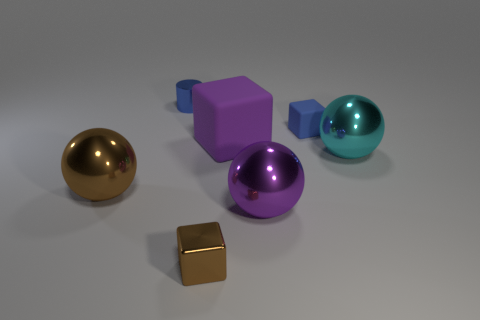Add 2 large cyan cylinders. How many objects exist? 9 Subtract all cylinders. How many objects are left? 6 Add 4 big brown balls. How many big brown balls are left? 5 Add 1 small cyan matte cubes. How many small cyan matte cubes exist? 1 Subtract 0 gray blocks. How many objects are left? 7 Subtract all cyan objects. Subtract all rubber objects. How many objects are left? 4 